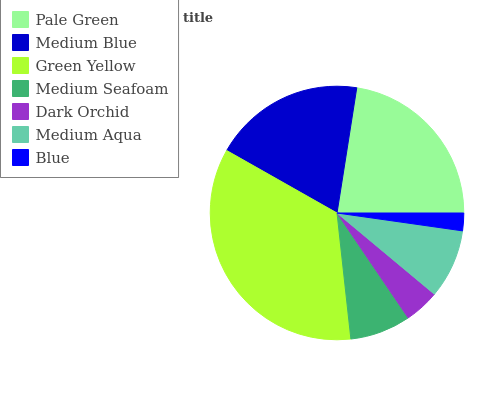Is Blue the minimum?
Answer yes or no. Yes. Is Green Yellow the maximum?
Answer yes or no. Yes. Is Medium Blue the minimum?
Answer yes or no. No. Is Medium Blue the maximum?
Answer yes or no. No. Is Pale Green greater than Medium Blue?
Answer yes or no. Yes. Is Medium Blue less than Pale Green?
Answer yes or no. Yes. Is Medium Blue greater than Pale Green?
Answer yes or no. No. Is Pale Green less than Medium Blue?
Answer yes or no. No. Is Medium Aqua the high median?
Answer yes or no. Yes. Is Medium Aqua the low median?
Answer yes or no. Yes. Is Green Yellow the high median?
Answer yes or no. No. Is Pale Green the low median?
Answer yes or no. No. 